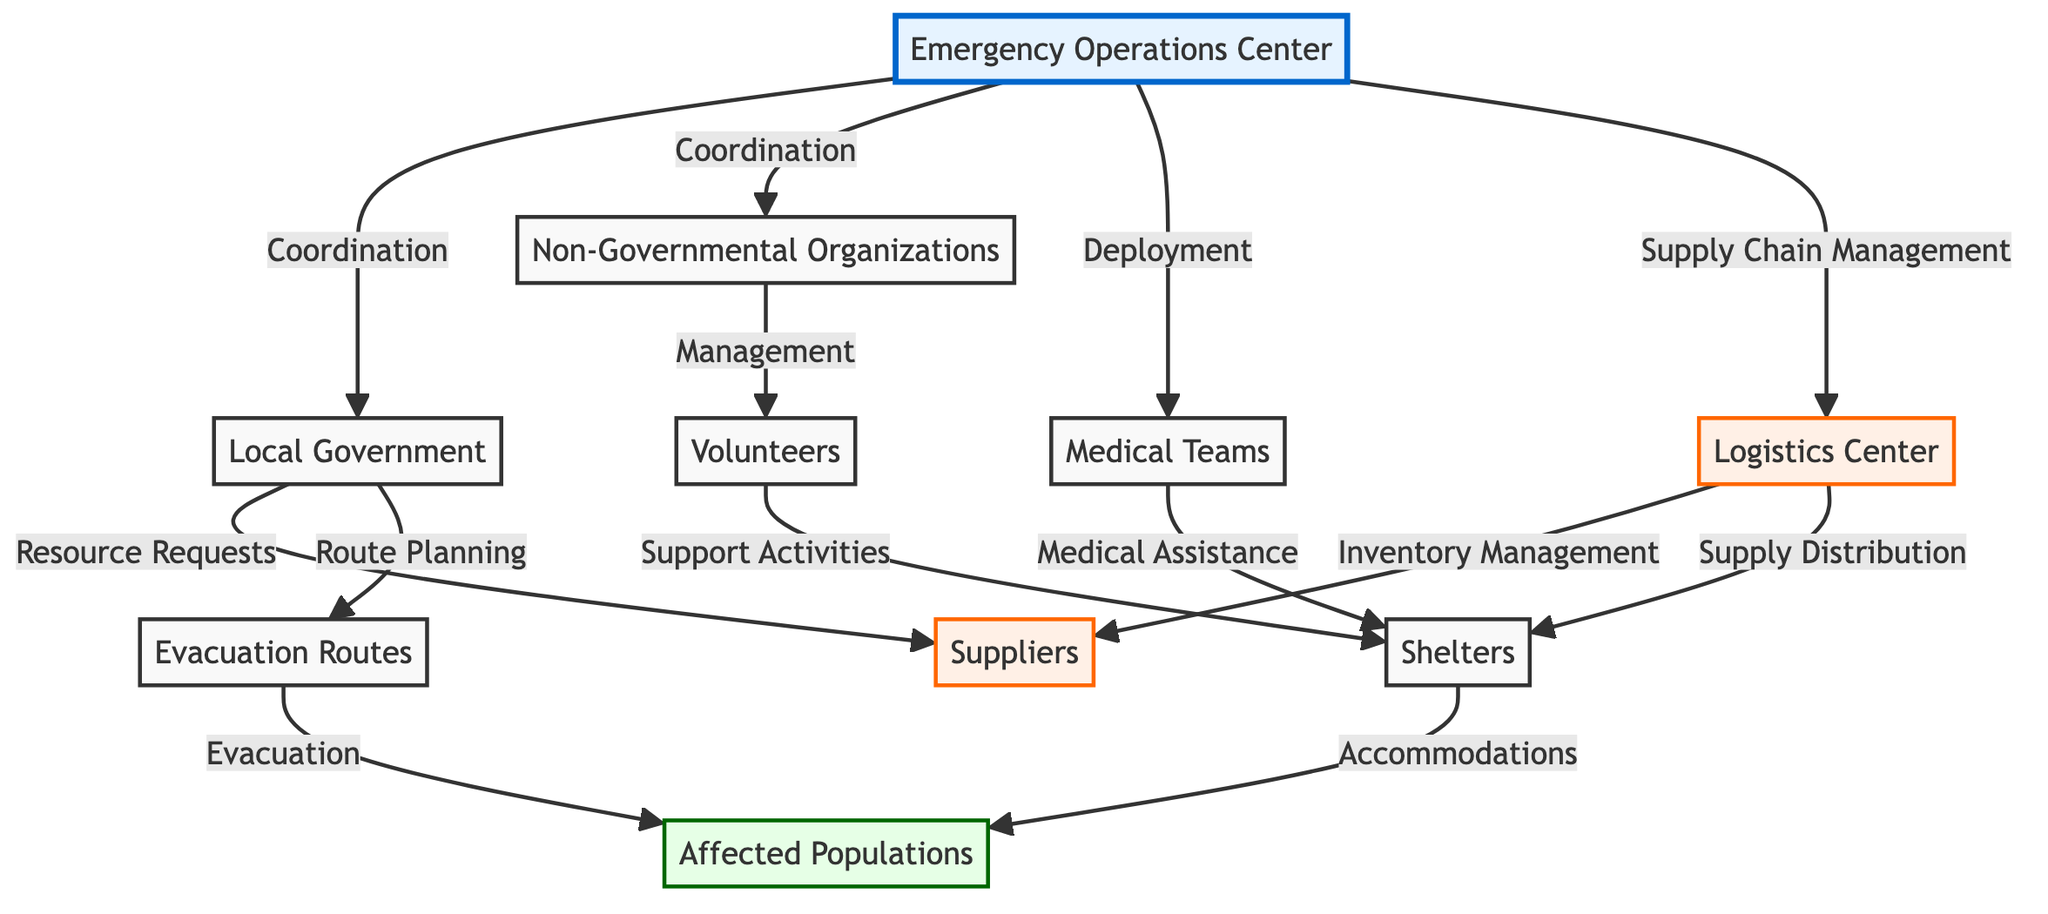What is the main node responsible for coordination in disaster response? The main node responsible for coordination is the Emergency Operations Center, as it has direct links labeled "Coordination" to both the Local Government and Non-Governmental Organizations.
Answer: Emergency Operations Center How many nodes are present in the diagram? There are a total of ten nodes in the diagram as listed: Emergency Operations Center, Local Government, NGOs, Medical Teams, Suppliers, Volunteers, Evacuation Routes, Shelters, Logistics Center, and Affected Populations.
Answer: 10 Which node is linked to both Medical Teams and Shelters? The node that links to both Medical Teams and Shelters is the Logistics Center, as it provides the supply distribution necessary for the shelters and medical assistance support.
Answer: Logistics Center What type of relationship exists between Local Government and Suppliers? The relationship between Local Government and Suppliers is characterized as "Resource Requests," indicating that the Local Government requests resources from the Suppliers during a disaster response.
Answer: Resource Requests Who manages volunteers according to the diagram? The Non-Governmental Organizations manage volunteers, as indicated by the link labeled "Management" directly connecting NGOs to Volunteers.
Answer: Non-Governmental Organizations In what way do Evacuation Routes contribute to the Affected Populations? Evacuation Routes contribute to Affected Populations through the labeled relationship "Evacuation," facilitating the movement of individuals from affected areas to safety.
Answer: Evacuation What is being supplied to Shelters from the Logistics Center? The Logistics Center supplies "Supply Distribution" to Shelters, which encompasses the essential resources and logistics needed for accommodating affected individuals.
Answer: Supply Distribution How does the Emergency Operations Center facilitate Medical Teams? The Emergency Operations Center facilitates Medical Teams through "Deployment," allowing for the strategic sending of medical resources and personnel where they're needed most during a disaster.
Answer: Deployment What action is linked between Shelters and Affected Populations? The action linked between Shelters and Affected Populations is "Accommodations," which highlights the role of shelters in providing housing and support to individuals who have been affected by the disaster.
Answer: Accommodations 